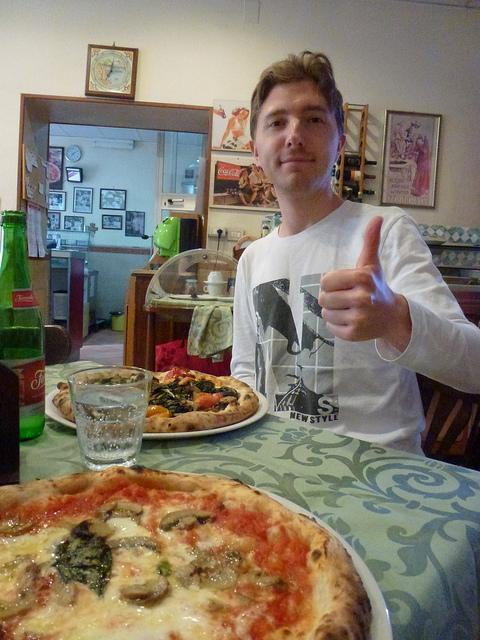Why is the man giving a thumbs up to the viewer?

Choices:
A) showing approval
B) showing off
C) rating movies
D) playing prank showing approval 